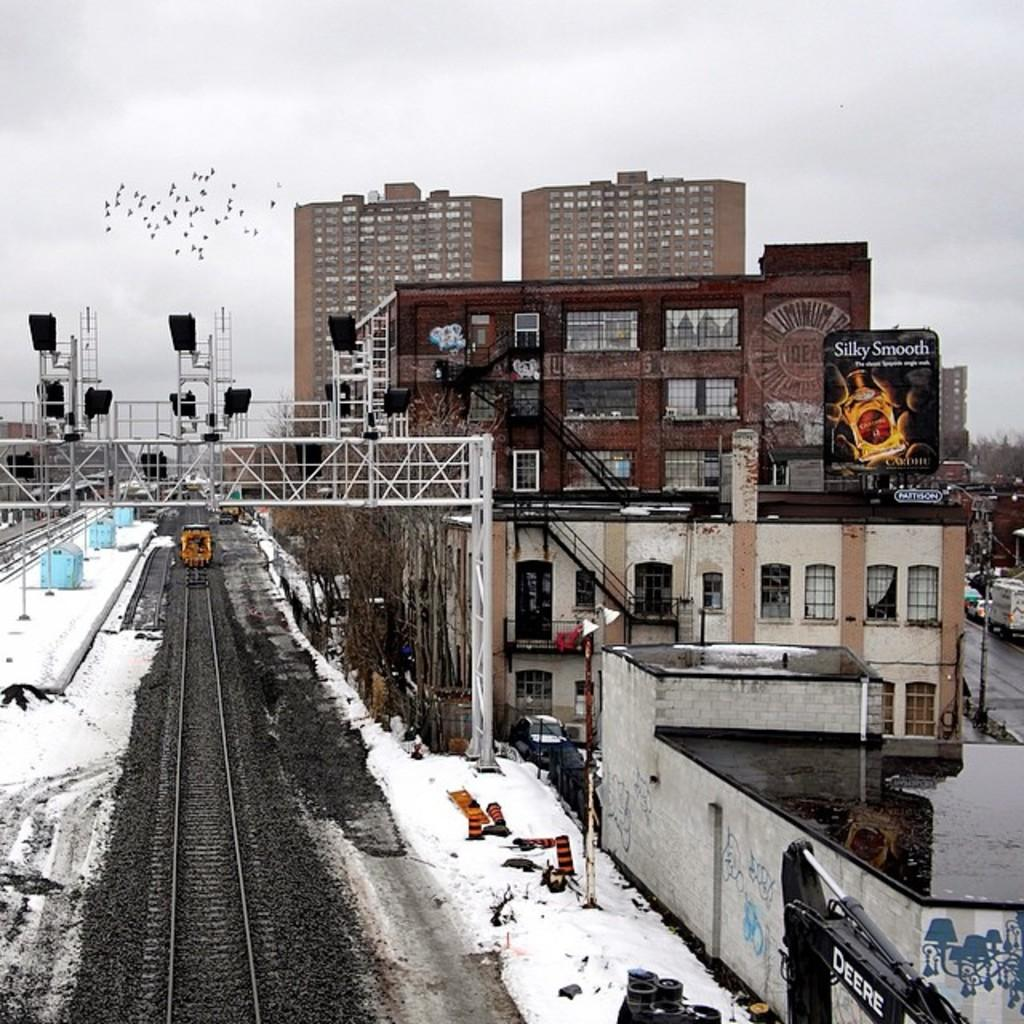What can be seen on the left side of the image? There is a railway track on the left side of the image. What is the weather like in the image? There is snow in the image, indicating a cold or wintry weather. What type of structures are visible on the right side of the image? There are big buildings on the right side of the image. What is the condition of the sky in the image? The sky is cloudy in the image. How many babies are present in the image? There are no babies present in the image. What type of house can be seen in the image? There is no house present in the image; it features a railway track, snow, big buildings, and a cloudy sky. 